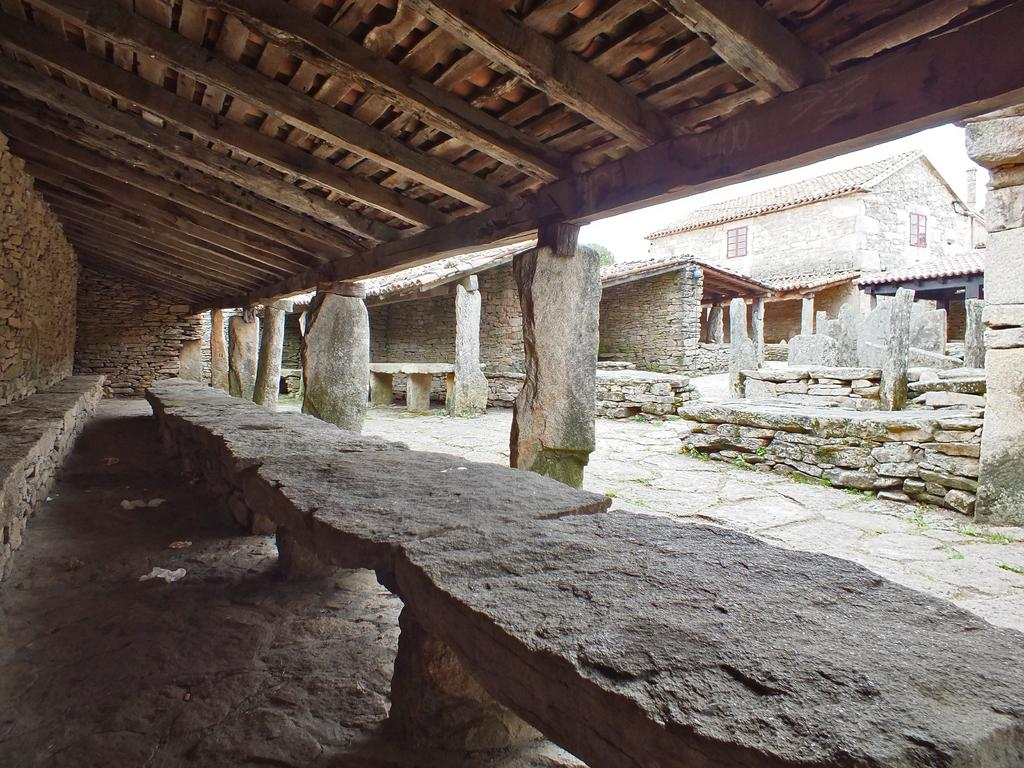What type of structures can be seen in the image? There are buildings in the image. What type of seating is present in the image? There are stone seats in the image. What can be found on the ground on the left side of the image? There are white-colored objects on the ground on the left side of the image. Where is the jail located in the image? There is no jail present in the image. What type of transportation can be seen at the station in the image? There is no station present in the image. 